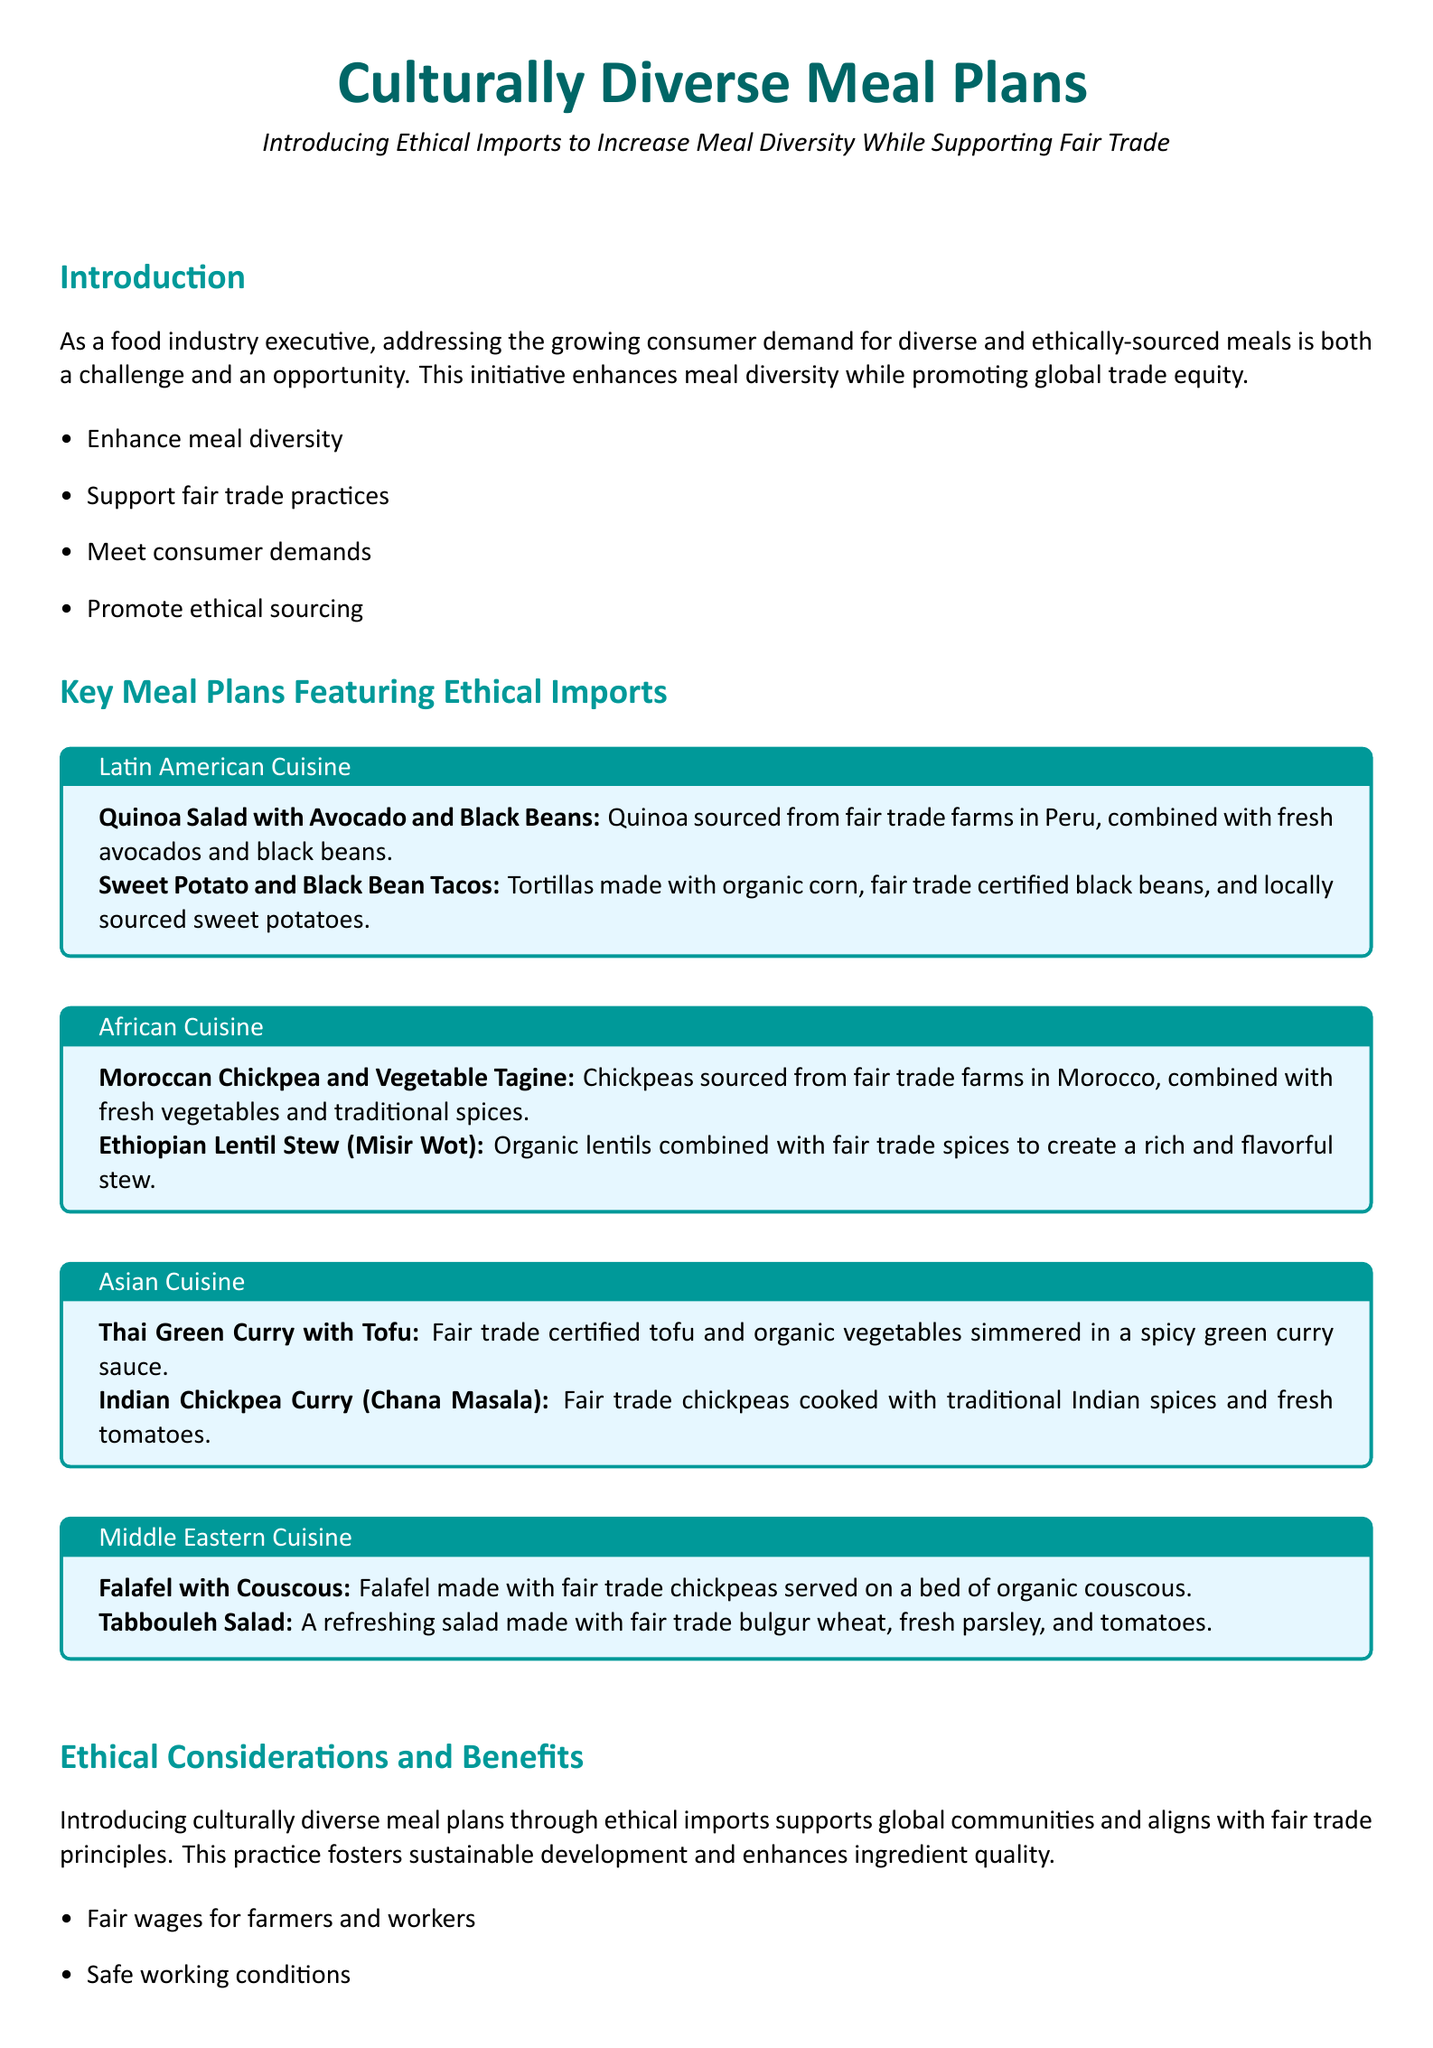What are the key focuses of the initiative? The key focuses of the initiative are enhancing meal diversity, supporting fair trade practices, meeting consumer demands, and promoting ethical sourcing.
Answer: Enhance meal diversity, support fair trade practices, meet consumer demands, promote ethical sourcing What ingredients are used in the Moroccan Chickpea and Vegetable Tagine? The ingredients stated for the Moroccan dish include chickpeas, fresh vegetables, and traditional spices.
Answer: Chickpeas, fresh vegetables, traditional spices Which fair trade ingredient is used in the Indian Chickpea Curry? The document specifies that fair trade chickpeas are used in the Indian chickpea curry.
Answer: Fair trade chickpeas What are the ethical benefits of introducing diverse meal plans? The ethical benefits mentioned include fair wages for farmers and workers, safe working conditions, sustainable practices, and enhanced ingredient quality.
Answer: Fair wages for farmers and workers, safe working conditions, sustainable and eco-friendly practices, enhanced ingredient quality How many meal plans are listed under Latin American cuisine? The Latin American section features two meal plans.
Answer: Two meal plans What type of cuisine includes Falafel with Couscous? The document categorizes Falafel with Couscous under Middle Eastern cuisine.
Answer: Middle Eastern cuisine What is the main ingredient in the Thai Green Curry with Tofu? The main ingredient specified for Thai Green Curry is fair trade certified tofu.
Answer: Fair trade certified tofu How many sections are there in the document's meal plans? The document outlines four distinct sections for meal plans.
Answer: Four sections 